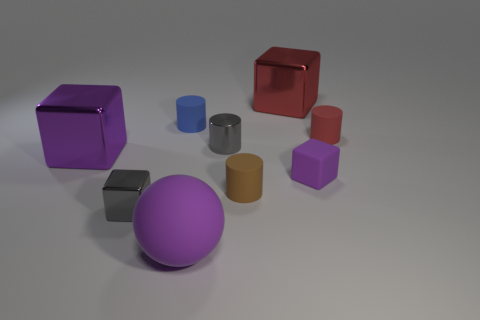There is another block that is the same color as the matte block; what material is it?
Provide a short and direct response. Metal. There is a big purple thing behind the large purple matte sphere; is it the same shape as the purple matte thing behind the tiny gray cube?
Make the answer very short. Yes. Are the cube behind the red cylinder and the large cube to the left of the small blue matte thing made of the same material?
Give a very brief answer. Yes. The cylinder in front of the large cube that is to the left of the large purple matte sphere is made of what material?
Make the answer very short. Rubber. There is a metal object on the right side of the tiny gray thing that is right of the tiny rubber cylinder that is left of the metallic cylinder; what shape is it?
Offer a terse response. Cube. What material is the tiny red object that is the same shape as the small blue object?
Offer a terse response. Rubber. How many purple shiny objects are there?
Keep it short and to the point. 1. There is a small purple rubber object that is in front of the large red object; what is its shape?
Make the answer very short. Cube. What color is the big shiny object that is behind the small red cylinder right of the tiny gray object that is on the left side of the big purple ball?
Your response must be concise. Red. What shape is the large object that is made of the same material as the small purple thing?
Your answer should be compact. Sphere. 